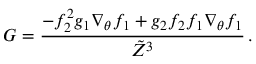<formula> <loc_0><loc_0><loc_500><loc_500>G = \frac { - f _ { 2 } ^ { 2 } g _ { 1 } \nabla _ { \theta } f _ { 1 } + g _ { 2 } f _ { 2 } f _ { 1 } \nabla _ { \theta } f _ { 1 } } { \tilde { Z } ^ { 3 } } \, .</formula> 